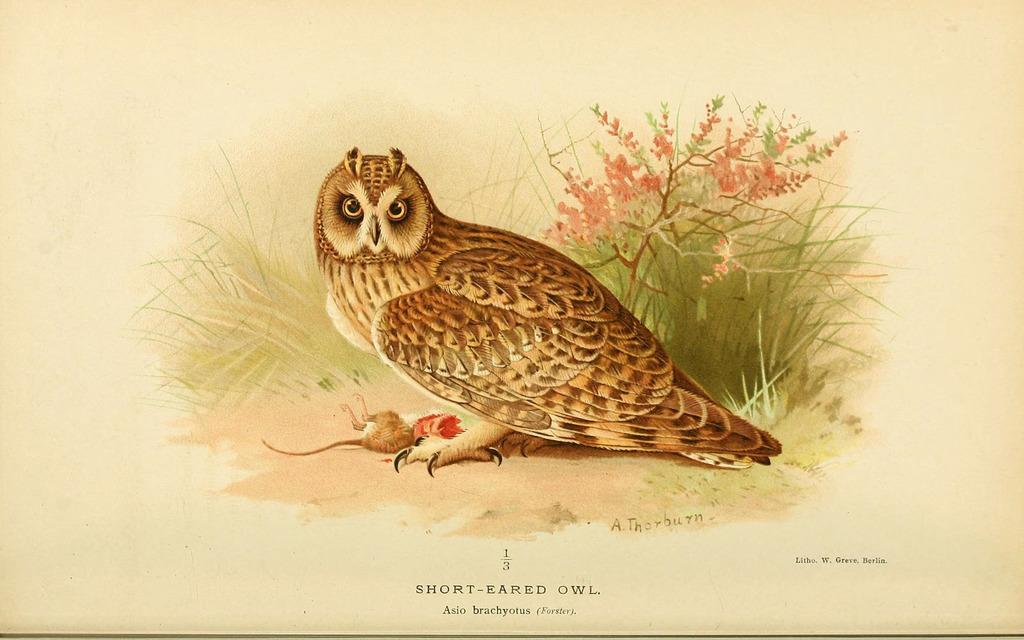What is depicted on the paper in the image? The paper contains a painting of an owl. What elements are included in the painting of the owl? The painting includes grass and flowers. What type of property is visible in the image? There is no property visible in the image; it only contains a painting of an owl on a piece of paper. How many bananas are included in the painting? There are no bananas present in the painting; it features an owl, grass, and flowers. 